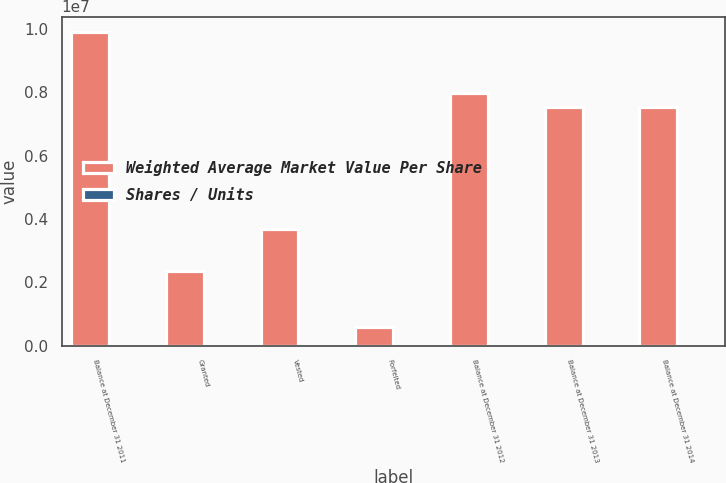Convert chart. <chart><loc_0><loc_0><loc_500><loc_500><stacked_bar_chart><ecel><fcel>Balance at December 31 2011<fcel>Granted<fcel>Vested<fcel>Forfeited<fcel>Balance at December 31 2012<fcel>Balance at December 31 2013<fcel>Balance at December 31 2014<nl><fcel>Weighted Average Market Value Per Share<fcel>9.88621e+06<fcel>2.35349e+06<fcel>3.67769e+06<fcel>588514<fcel>7.97349e+06<fcel>7.54151e+06<fcel>7.5421e+06<nl><fcel>Shares / Units<fcel>15.18<fcel>20.31<fcel>13.18<fcel>14.55<fcel>17.65<fcel>20.76<fcel>22.53<nl></chart> 